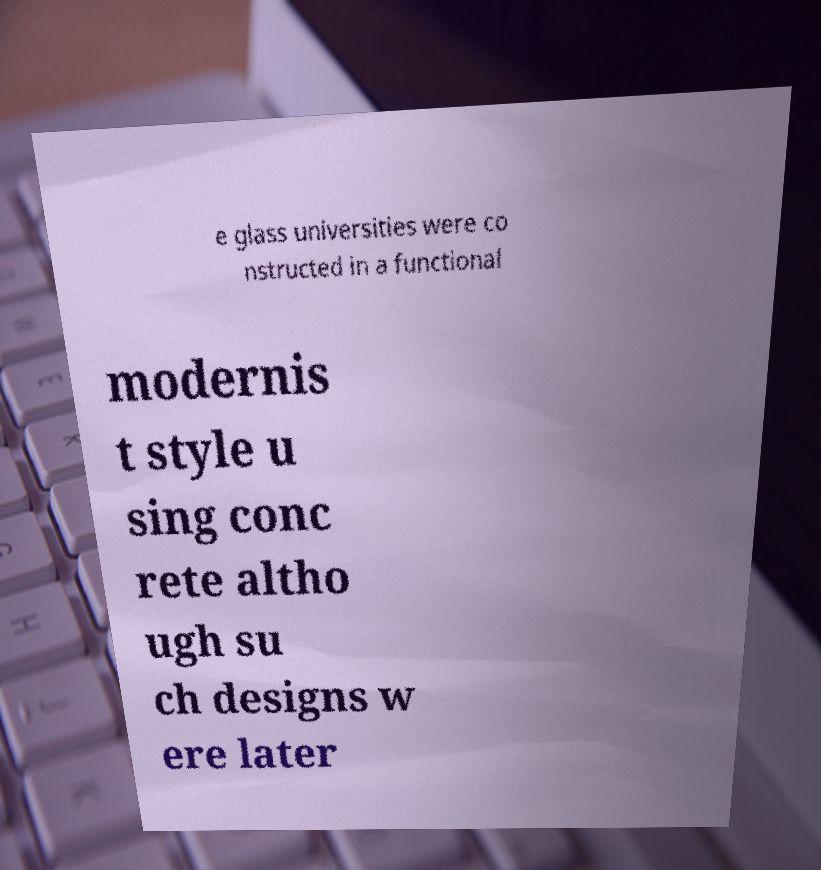There's text embedded in this image that I need extracted. Can you transcribe it verbatim? e glass universities were co nstructed in a functional modernis t style u sing conc rete altho ugh su ch designs w ere later 